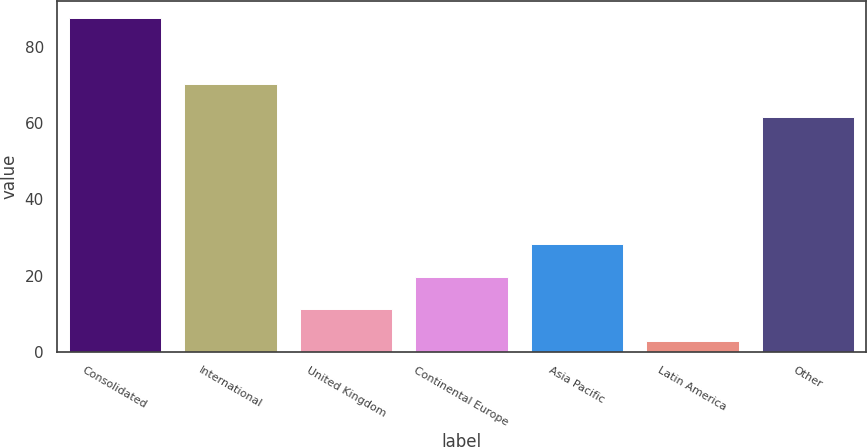<chart> <loc_0><loc_0><loc_500><loc_500><bar_chart><fcel>Consolidated<fcel>International<fcel>United Kingdom<fcel>Continental Europe<fcel>Asia Pacific<fcel>Latin America<fcel>Other<nl><fcel>87.6<fcel>70.18<fcel>11.28<fcel>19.76<fcel>28.24<fcel>2.8<fcel>61.7<nl></chart> 